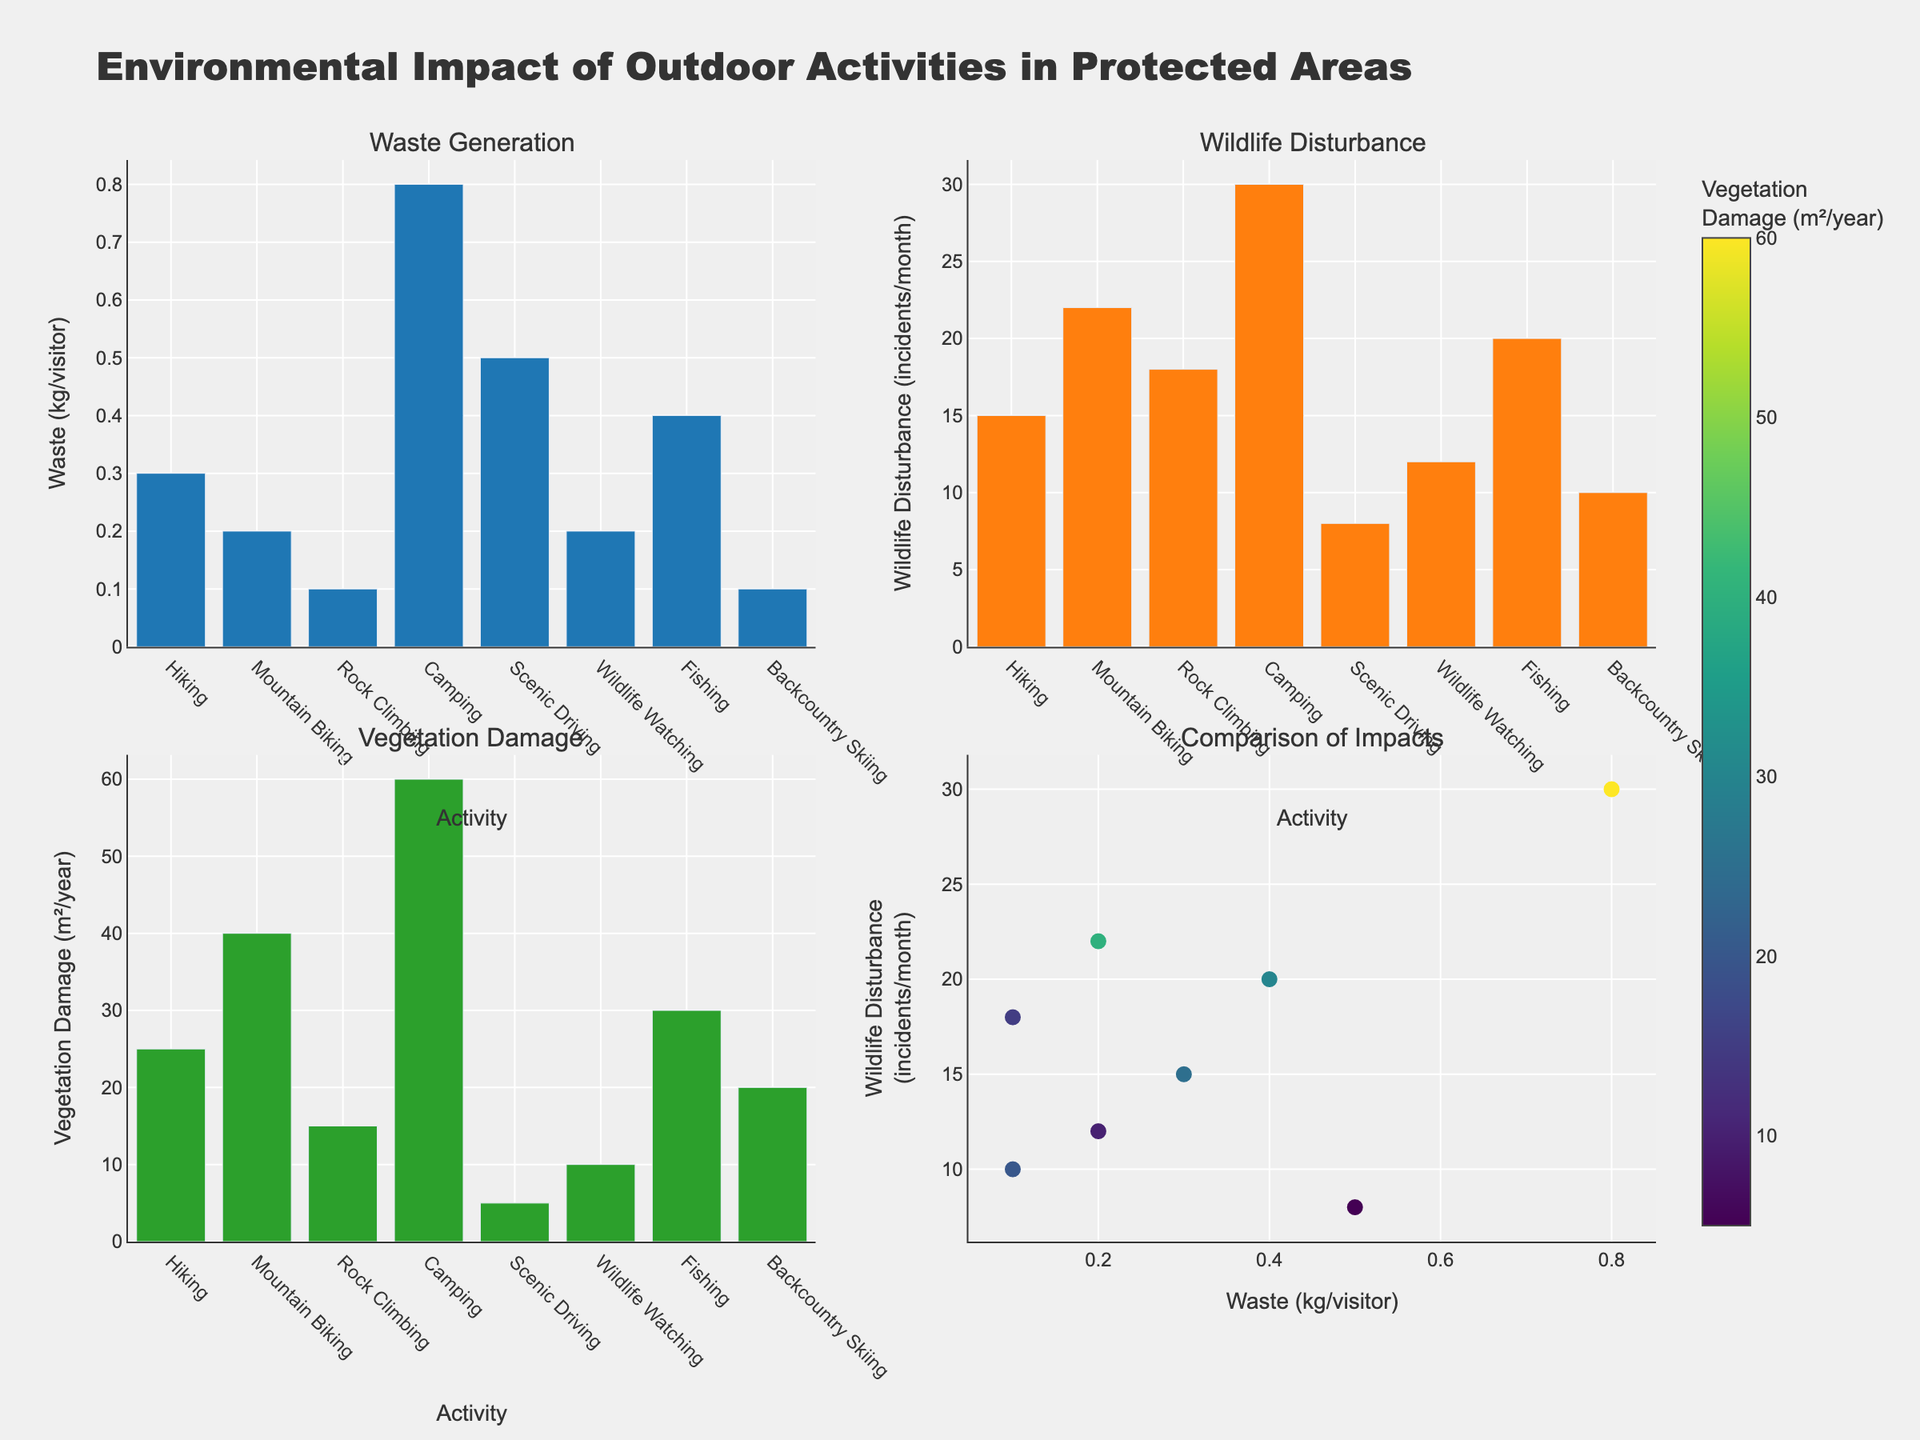what is the title of the grid plot? The title is displayed at the top of the figure in large, bold text.
Answer: Evolution of Gospel Music Instrumentation (1920-2020) what is the peak prevalence of the Piano, and in which year did it occur? On the subplot related to Piano, the highest point on the y-axis (prevalence) corresponds to the year 1980, where it reaches close to 95%.
Answer: 1980 which instrument shows a consistent increase in prevalence between each year? By looking at each subplot, the Guitar shows a consistent increase in prevalence over each year from 1920 to 2020.
Answer: Guitar what's the difference in Drum prevalence between the years 1920 and 2020? On the Drums subplot, note the y-values for 1920 and 2020, which are 5% and 75% respectively. Subtract the earlier value from the later one to get the difference: 75% - 5% = 70%.
Answer: 70% which instrument becomes less prevalent between the years 1980 and 2020? By comparing the y-values in their respective subplots for 1980 and 2020, we can see that while many instruments increase in prevalence, the Organ shows a decrease from 85% to 70%.
Answer: Organ Which instrument had no prevalence in 1920 but appeared in later years? In the subplot data points for each instrument, the Bass and Saxophone are at 0% in 1920 but have values in subsequent years.
Answer: Bass and Saxophone Between 1960 and 2000, which instrument shows the largest absolute growth in prevalence? Calculate the difference in prevalence for each instrument between 1960 and 2000. For the Guitar, 70% - 40% = 30%, which is the highest growth compared to other instruments.
Answer: Guitar How do the prevalence patterns of the Trumpet and Saxophone differ over time? Examine their respective subplots, noting that the Trumpet shows a steady increase while the Saxophone shows a more modest, somewhat slower rise.
Answer: The Trumpet has a steady increase, Saxophone has a modest rise which instrument had the highest prevalence in the year 2000? In the subplots for the year 2000, the Piano has the highest y-value which appears to be just under 90%.
Answer: Piano How does the prevalence of the Tambourine change from 1920 to 1960? Looking at the Tambourine subplot, it rises from 30% in 1920 to 50% in 1960, showing an increase.
Answer: Increase 